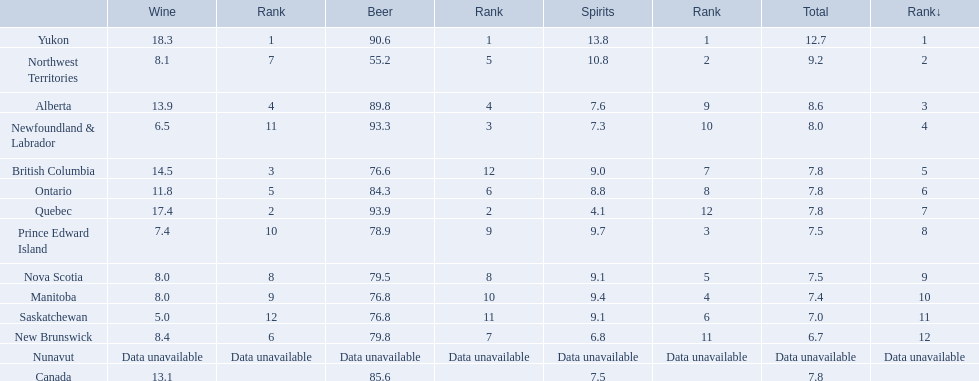What is the first ranked alcoholic beverage in canada Yukon. How many litters is consumed a year? 12.7. 